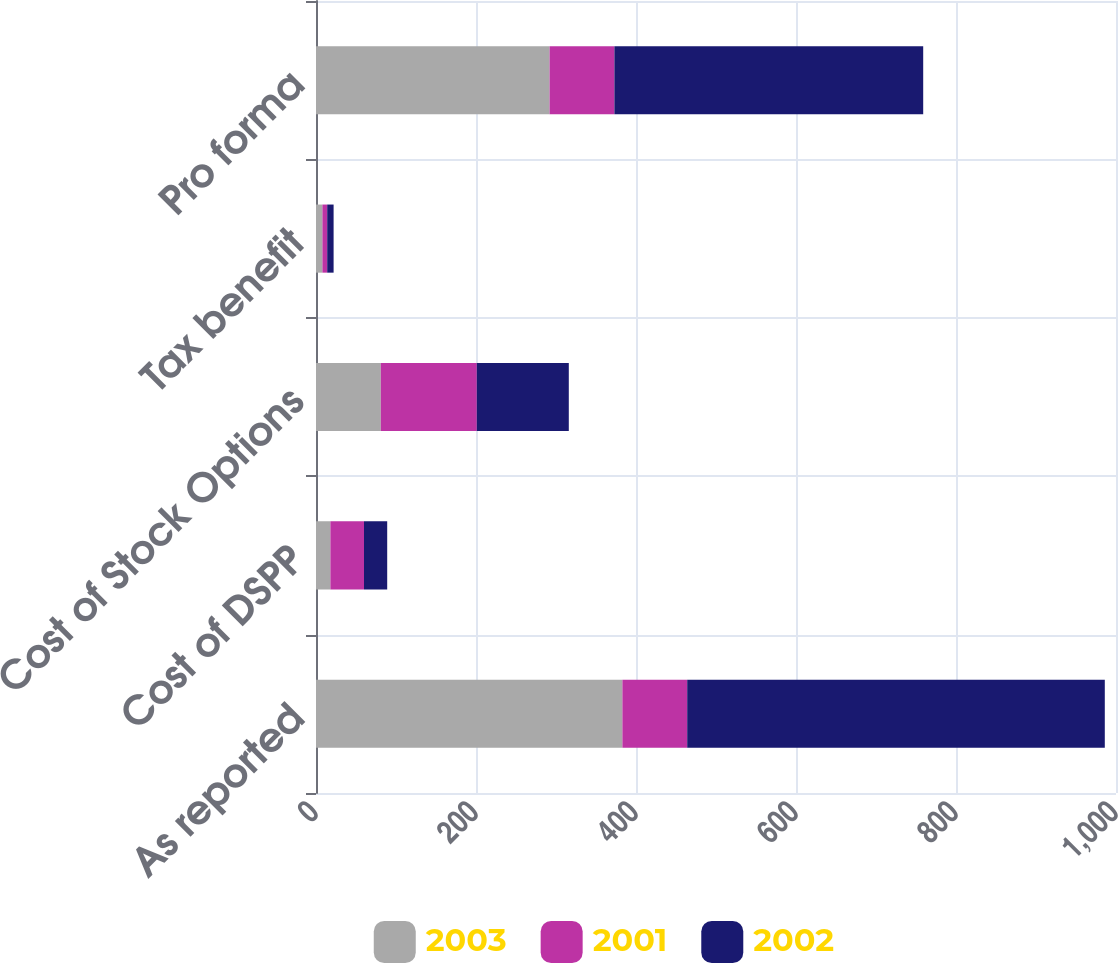Convert chart to OTSL. <chart><loc_0><loc_0><loc_500><loc_500><stacked_bar_chart><ecel><fcel>As reported<fcel>Cost of DSPP<fcel>Cost of Stock Options<fcel>Tax benefit<fcel>Pro forma<nl><fcel>2003<fcel>383<fcel>18<fcel>81<fcel>8<fcel>292<nl><fcel>2001<fcel>81<fcel>42<fcel>120<fcel>6<fcel>81<nl><fcel>2002<fcel>522<fcel>29<fcel>115<fcel>8<fcel>386<nl></chart> 